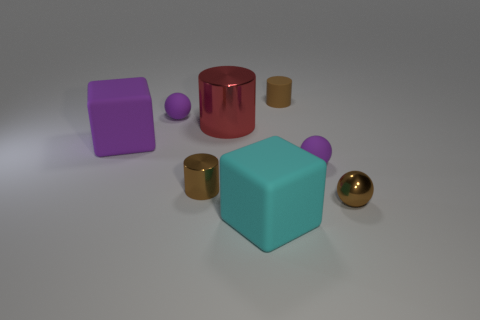The small rubber object that is the same color as the tiny metal cylinder is what shape?
Provide a short and direct response. Cylinder. There is a big red object that is to the left of the cyan thing; is it the same shape as the small purple thing to the right of the tiny brown rubber thing?
Offer a terse response. No. There is another rubber object that is the same shape as the cyan rubber thing; what size is it?
Offer a terse response. Large. What number of tiny brown blocks have the same material as the cyan block?
Ensure brevity in your answer.  0. What is the brown sphere made of?
Give a very brief answer. Metal. There is a tiny object that is right of the purple object to the right of the large red metallic thing; what shape is it?
Keep it short and to the point. Sphere. What shape is the tiny brown shiny object that is behind the brown metallic ball?
Your answer should be compact. Cylinder. What number of rubber cubes have the same color as the big shiny cylinder?
Your answer should be compact. 0. The small rubber cylinder has what color?
Provide a succinct answer. Brown. What number of spheres are behind the matte sphere that is on the left side of the small brown rubber cylinder?
Provide a short and direct response. 0. 